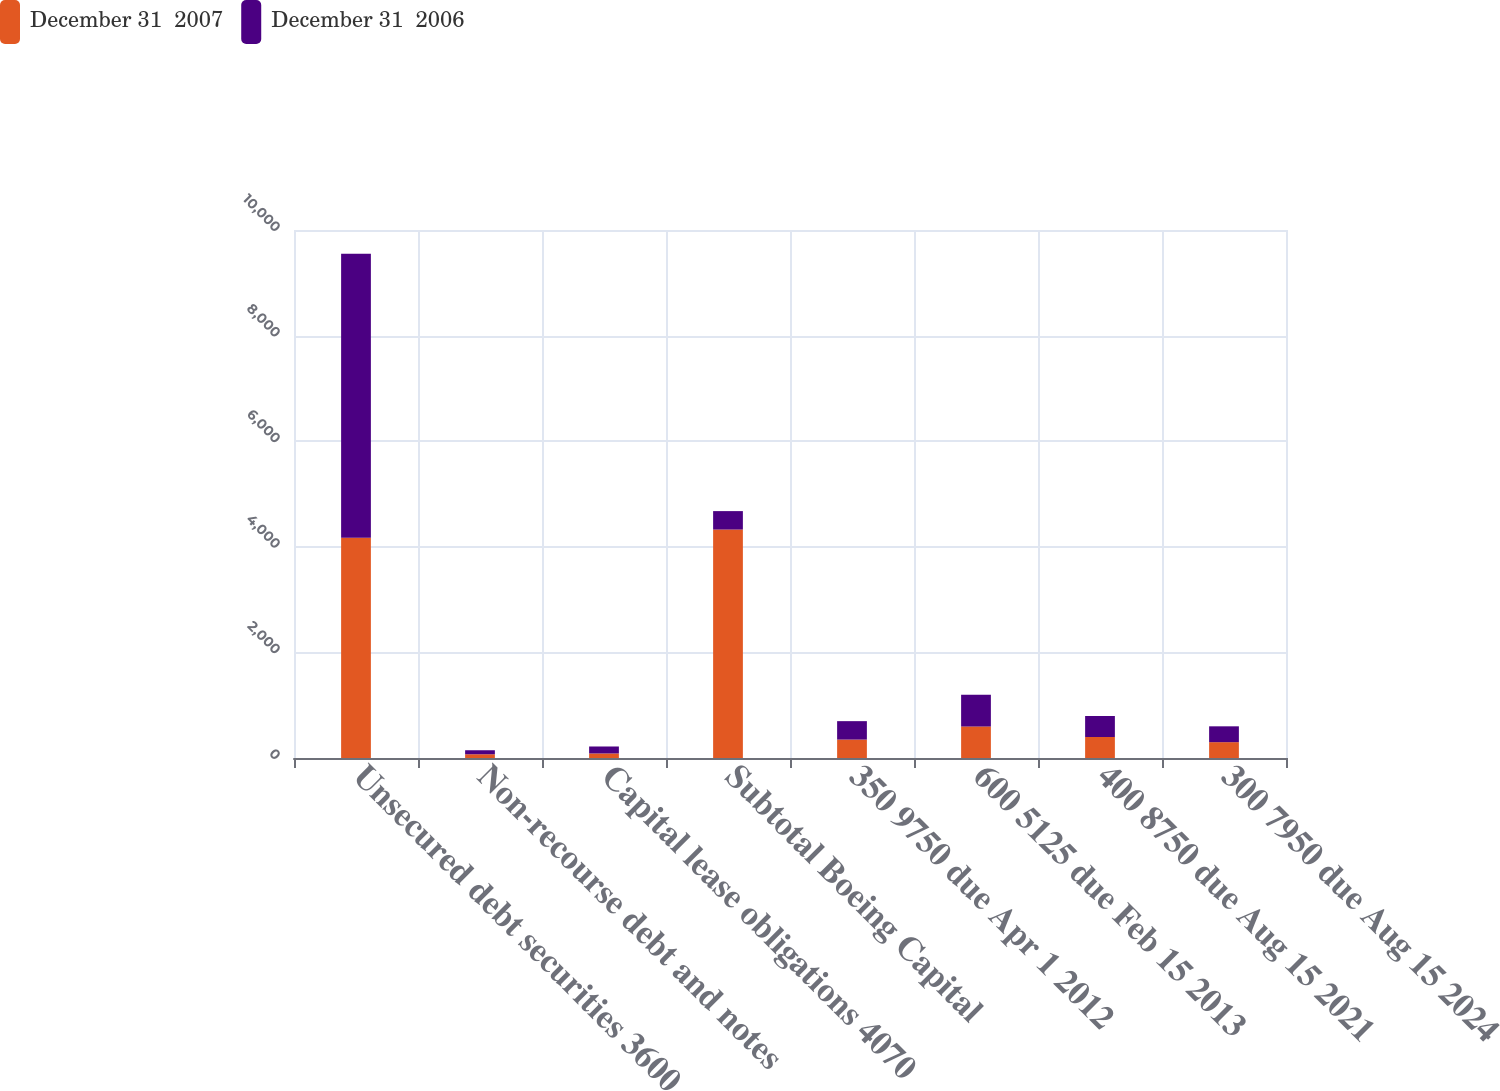Convert chart. <chart><loc_0><loc_0><loc_500><loc_500><stacked_bar_chart><ecel><fcel>Unsecured debt securities 3600<fcel>Non-recourse debt and notes<fcel>Capital lease obligations 4070<fcel>Subtotal Boeing Capital<fcel>350 9750 due Apr 1 2012<fcel>600 5125 due Feb 15 2013<fcel>400 8750 due Aug 15 2021<fcel>300 7950 due Aug 15 2024<nl><fcel>December 31  2007<fcel>4170<fcel>71<fcel>86<fcel>4327<fcel>349<fcel>598<fcel>398<fcel>300<nl><fcel>December 31  2006<fcel>5382<fcel>76<fcel>132<fcel>349<fcel>349<fcel>598<fcel>398<fcel>300<nl></chart> 